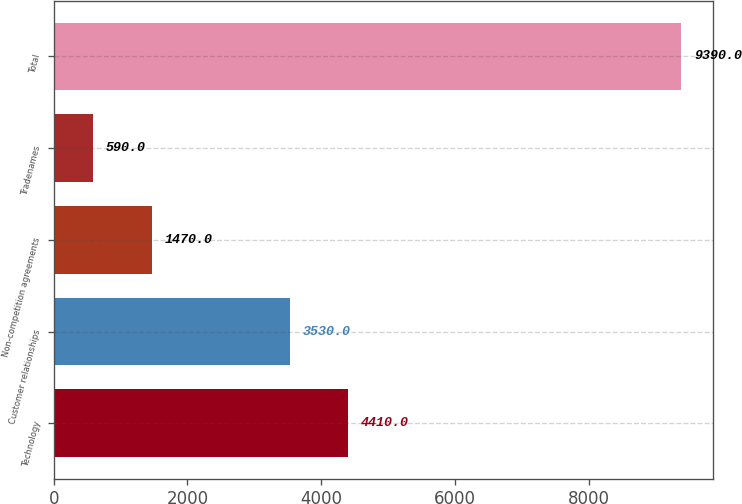<chart> <loc_0><loc_0><loc_500><loc_500><bar_chart><fcel>Technology<fcel>Customer relationships<fcel>Non-competition agreements<fcel>Tradenames<fcel>Total<nl><fcel>4410<fcel>3530<fcel>1470<fcel>590<fcel>9390<nl></chart> 